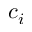Convert formula to latex. <formula><loc_0><loc_0><loc_500><loc_500>c _ { i }</formula> 